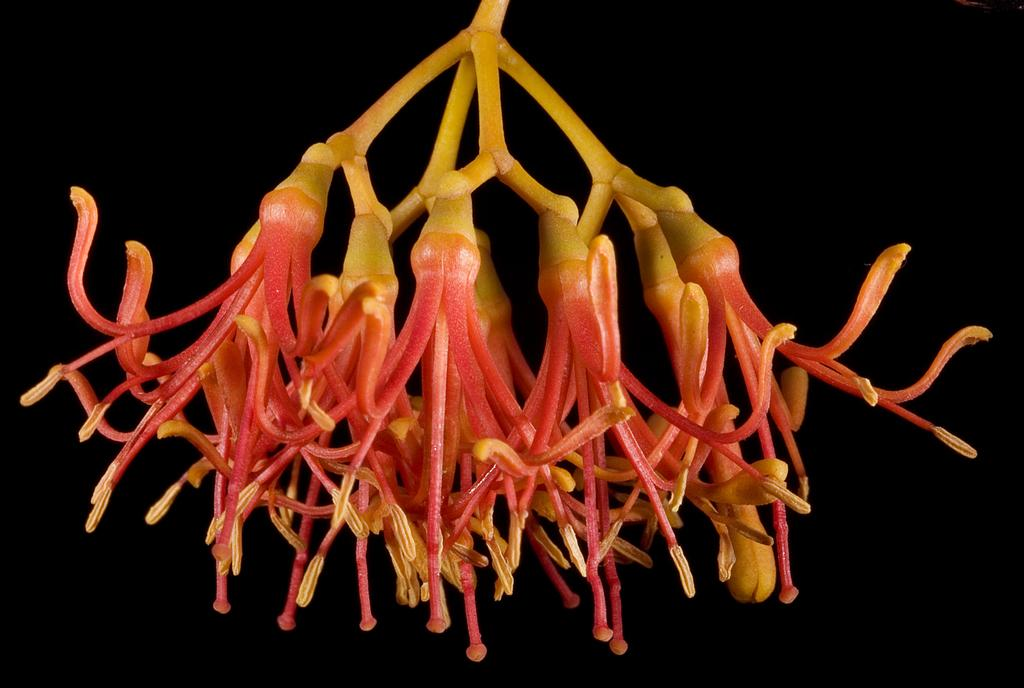What is the main component of the flowers in the image? There is a stem in the image, which is a part of the flowers. Can you describe the flowers in the image? Yes, there are flowers in the image. How many times does the flower jump in the image? There is no indication of the flower jumping in the image, as flowers do not have the ability to jump. 